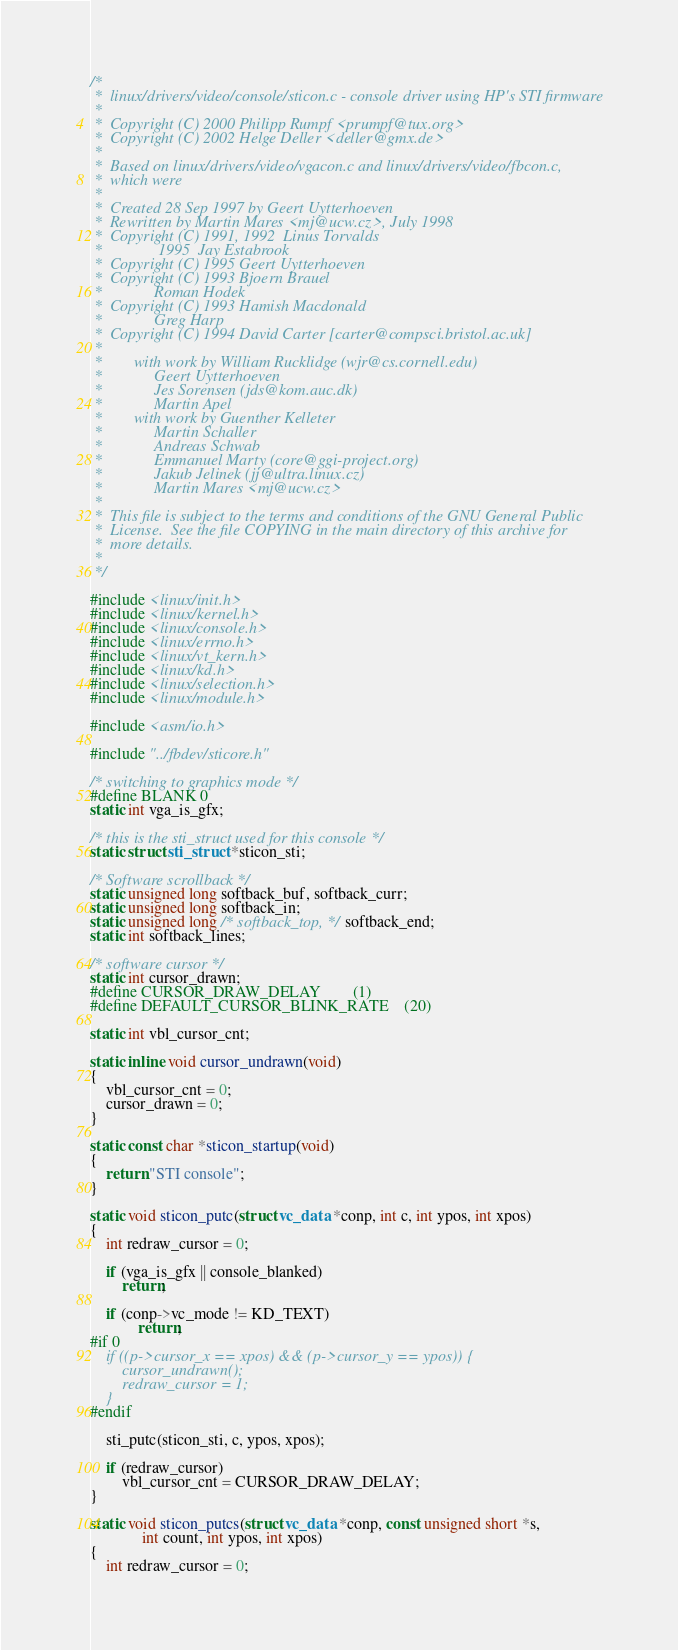<code> <loc_0><loc_0><loc_500><loc_500><_C_>/*
 *  linux/drivers/video/console/sticon.c - console driver using HP's STI firmware
 *
 *	Copyright (C) 2000 Philipp Rumpf <prumpf@tux.org>
 *	Copyright (C) 2002 Helge Deller <deller@gmx.de>
 *
 *  Based on linux/drivers/video/vgacon.c and linux/drivers/video/fbcon.c,
 *  which were
 *
 *	Created 28 Sep 1997 by Geert Uytterhoeven
 *	Rewritten by Martin Mares <mj@ucw.cz>, July 1998
 *	Copyright (C) 1991, 1992  Linus Torvalds
 *			    1995  Jay Estabrook
 *	Copyright (C) 1995 Geert Uytterhoeven
 *	Copyright (C) 1993 Bjoern Brauel
 *			   Roman Hodek
 *	Copyright (C) 1993 Hamish Macdonald
 *			   Greg Harp
 *	Copyright (C) 1994 David Carter [carter@compsci.bristol.ac.uk]
 *
 *	      with work by William Rucklidge (wjr@cs.cornell.edu)
 *			   Geert Uytterhoeven
 *			   Jes Sorensen (jds@kom.auc.dk)
 *			   Martin Apel
 *	      with work by Guenther Kelleter
 *			   Martin Schaller
 *			   Andreas Schwab
 *			   Emmanuel Marty (core@ggi-project.org)
 *			   Jakub Jelinek (jj@ultra.linux.cz)
 *			   Martin Mares <mj@ucw.cz>
 *
 *  This file is subject to the terms and conditions of the GNU General Public
 *  License.  See the file COPYING in the main directory of this archive for
 *  more details.
 *
 */

#include <linux/init.h>
#include <linux/kernel.h>
#include <linux/console.h>
#include <linux/errno.h>
#include <linux/vt_kern.h>
#include <linux/kd.h>
#include <linux/selection.h>
#include <linux/module.h>

#include <asm/io.h>

#include "../fbdev/sticore.h"

/* switching to graphics mode */
#define BLANK 0
static int vga_is_gfx;

/* this is the sti_struct used for this console */
static struct sti_struct *sticon_sti;

/* Software scrollback */
static unsigned long softback_buf, softback_curr;
static unsigned long softback_in;
static unsigned long /* softback_top, */ softback_end;
static int softback_lines;

/* software cursor */
static int cursor_drawn;
#define CURSOR_DRAW_DELAY		(1)
#define DEFAULT_CURSOR_BLINK_RATE	(20)

static int vbl_cursor_cnt;

static inline void cursor_undrawn(void)
{
    vbl_cursor_cnt = 0;
    cursor_drawn = 0;
}

static const char *sticon_startup(void)
{
    return "STI console";
}

static void sticon_putc(struct vc_data *conp, int c, int ypos, int xpos)
{
    int redraw_cursor = 0;

    if (vga_is_gfx || console_blanked)
	    return;

    if (conp->vc_mode != KD_TEXT)
    	    return;
#if 0
    if ((p->cursor_x == xpos) && (p->cursor_y == ypos)) {
	    cursor_undrawn();
	    redraw_cursor = 1;
    }
#endif

    sti_putc(sticon_sti, c, ypos, xpos);

    if (redraw_cursor)
	    vbl_cursor_cnt = CURSOR_DRAW_DELAY;
}

static void sticon_putcs(struct vc_data *conp, const unsigned short *s,
			 int count, int ypos, int xpos)
{
    int redraw_cursor = 0;
</code> 